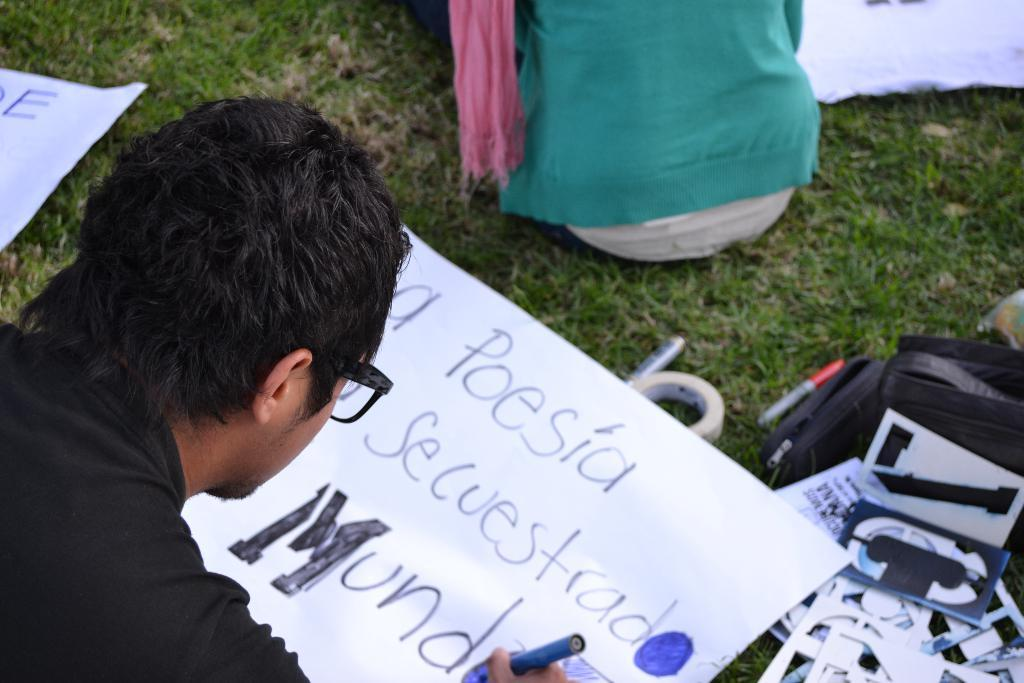Who is present in the image? There are people in the image. What are the people doing in the image? The people are sitting on the grass and writing on charts. What type of fear is depicted in the image? There is no fear depicted in the image; it features people sitting on the grass and writing on charts. 